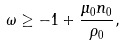Convert formula to latex. <formula><loc_0><loc_0><loc_500><loc_500>\omega \geq - 1 + \frac { \mu _ { 0 } n _ { 0 } } { \rho _ { 0 } } ,</formula> 